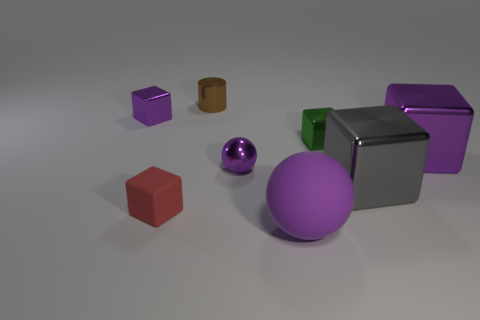Subtract all cyan balls. How many purple blocks are left? 2 Subtract all gray cubes. How many cubes are left? 4 Subtract all green blocks. How many blocks are left? 4 Subtract 2 blocks. How many blocks are left? 3 Add 2 green things. How many objects exist? 10 Subtract all gray cubes. Subtract all purple balls. How many cubes are left? 4 Add 7 tiny red cubes. How many tiny red cubes are left? 8 Add 1 tiny green things. How many tiny green things exist? 2 Subtract 0 red cylinders. How many objects are left? 8 Subtract all balls. How many objects are left? 6 